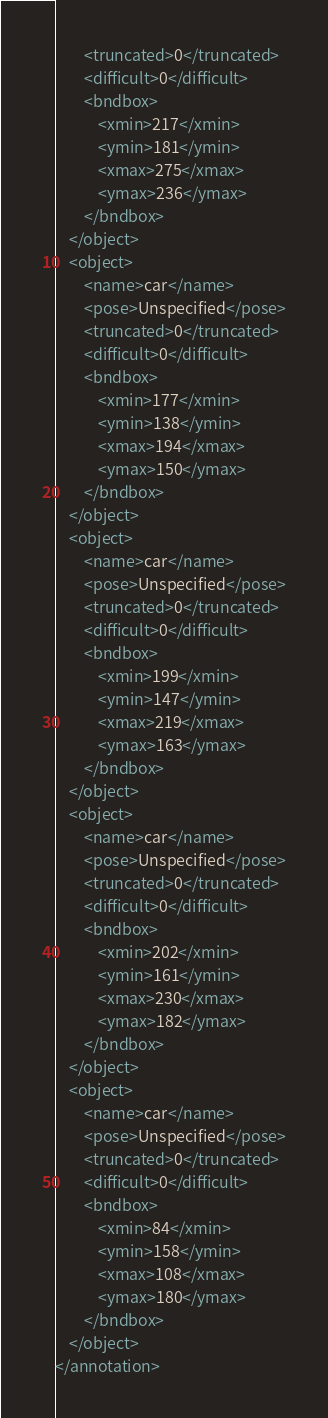<code> <loc_0><loc_0><loc_500><loc_500><_XML_>		<truncated>0</truncated>
		<difficult>0</difficult>
		<bndbox>
			<xmin>217</xmin>
			<ymin>181</ymin>
			<xmax>275</xmax>
			<ymax>236</ymax>
		</bndbox>
	</object>
	<object>
		<name>car</name>
		<pose>Unspecified</pose>
		<truncated>0</truncated>
		<difficult>0</difficult>
		<bndbox>
			<xmin>177</xmin>
			<ymin>138</ymin>
			<xmax>194</xmax>
			<ymax>150</ymax>
		</bndbox>
	</object>
	<object>
		<name>car</name>
		<pose>Unspecified</pose>
		<truncated>0</truncated>
		<difficult>0</difficult>
		<bndbox>
			<xmin>199</xmin>
			<ymin>147</ymin>
			<xmax>219</xmax>
			<ymax>163</ymax>
		</bndbox>
	</object>
	<object>
		<name>car</name>
		<pose>Unspecified</pose>
		<truncated>0</truncated>
		<difficult>0</difficult>
		<bndbox>
			<xmin>202</xmin>
			<ymin>161</ymin>
			<xmax>230</xmax>
			<ymax>182</ymax>
		</bndbox>
	</object>
	<object>
		<name>car</name>
		<pose>Unspecified</pose>
		<truncated>0</truncated>
		<difficult>0</difficult>
		<bndbox>
			<xmin>84</xmin>
			<ymin>158</ymin>
			<xmax>108</xmax>
			<ymax>180</ymax>
		</bndbox>
	</object>
</annotation>
</code> 